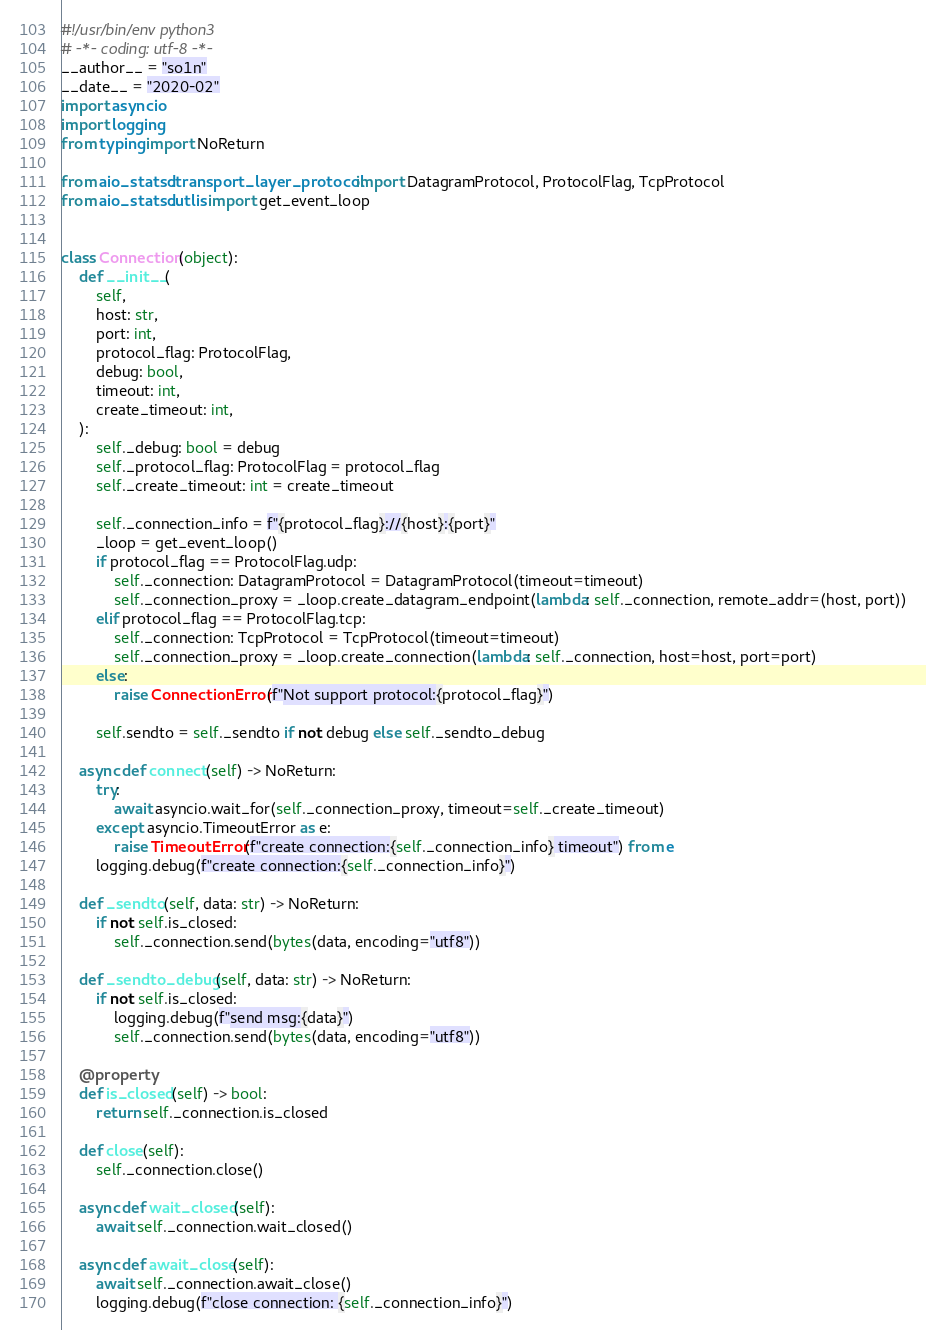<code> <loc_0><loc_0><loc_500><loc_500><_Python_>#!/usr/bin/env python3
# -*- coding: utf-8 -*-
__author__ = "so1n"
__date__ = "2020-02"
import asyncio
import logging
from typing import NoReturn

from aio_statsd.transport_layer_protocol import DatagramProtocol, ProtocolFlag, TcpProtocol
from aio_statsd.utlis import get_event_loop


class Connection(object):
    def __init__(
        self,
        host: str,
        port: int,
        protocol_flag: ProtocolFlag,
        debug: bool,
        timeout: int,
        create_timeout: int,
    ):
        self._debug: bool = debug
        self._protocol_flag: ProtocolFlag = protocol_flag
        self._create_timeout: int = create_timeout

        self._connection_info = f"{protocol_flag}://{host}:{port}"
        _loop = get_event_loop()
        if protocol_flag == ProtocolFlag.udp:
            self._connection: DatagramProtocol = DatagramProtocol(timeout=timeout)
            self._connection_proxy = _loop.create_datagram_endpoint(lambda: self._connection, remote_addr=(host, port))
        elif protocol_flag == ProtocolFlag.tcp:
            self._connection: TcpProtocol = TcpProtocol(timeout=timeout)
            self._connection_proxy = _loop.create_connection(lambda: self._connection, host=host, port=port)
        else:
            raise ConnectionError(f"Not support protocol:{protocol_flag}")

        self.sendto = self._sendto if not debug else self._sendto_debug

    async def connect(self) -> NoReturn:
        try:
            await asyncio.wait_for(self._connection_proxy, timeout=self._create_timeout)
        except asyncio.TimeoutError as e:
            raise TimeoutError(f"create connection:{self._connection_info} timeout") from e
        logging.debug(f"create connection:{self._connection_info}")

    def _sendto(self, data: str) -> NoReturn:
        if not self.is_closed:
            self._connection.send(bytes(data, encoding="utf8"))

    def _sendto_debug(self, data: str) -> NoReturn:
        if not self.is_closed:
            logging.debug(f"send msg:{data}")
            self._connection.send(bytes(data, encoding="utf8"))

    @property
    def is_closed(self) -> bool:
        return self._connection.is_closed

    def close(self):
        self._connection.close()

    async def wait_closed(self):
        await self._connection.wait_closed()

    async def await_close(self):
        await self._connection.await_close()
        logging.debug(f"close connection: {self._connection_info}")
</code> 